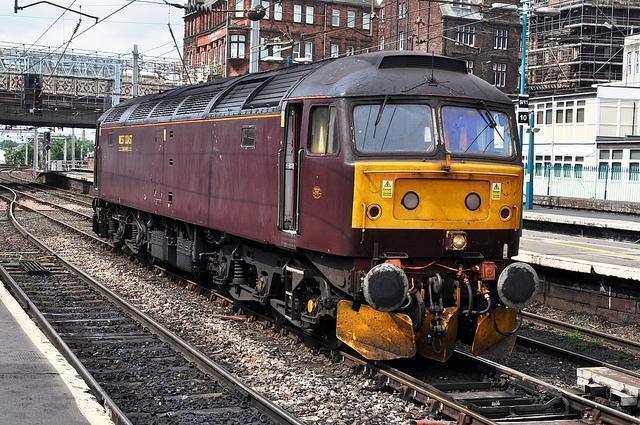What type of area is in the background?
Select the accurate response from the four choices given to answer the question.
Options: Forest, urban, rural, mountain. Urban. 